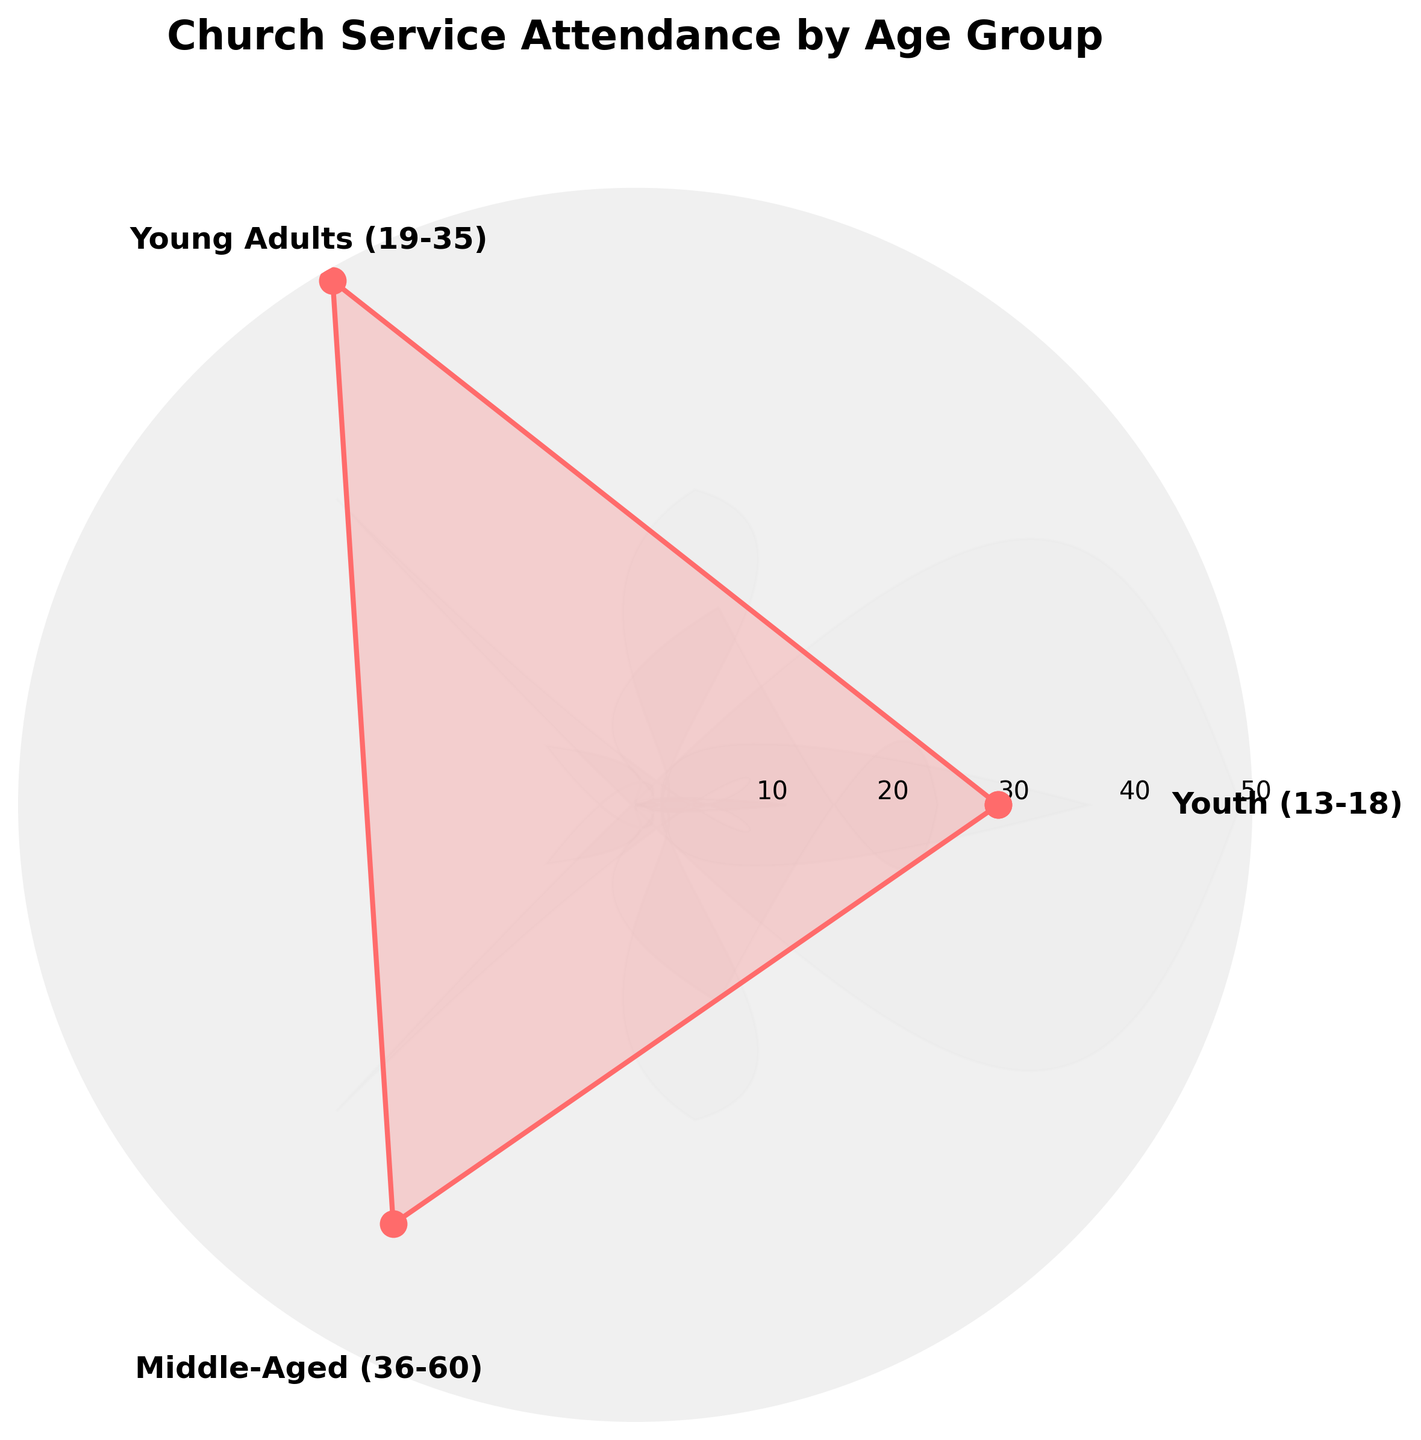What is the title of the figure? The title of the figure is displayed at the top and prominently set in bold.
Answer: Church Service Attendance by Age Group How many age groups are represented in this chart? The chart shows three labeled segments, signifying three age groups.
Answer: Three Which age group has the highest attendance? By observing the plot, the group with the largest distance from the center represents the highest attendance.
Answer: Young Adults (19-35) What is the attendance difference between the Youth (13-18) and Middle-Aged (36-60) groups? Subtract the attendance of the Youth group from that of the Middle-Aged group: 40 (Middle-Aged) - 30 (Youth) = 10
Answer: 10 Which age group has the smallest attendance? The group closest to the center of the plot represents the smallest attendance.
Answer: Youth (13-18) How does the attendance for Young Adults compare to the other age groups? The plot shows that the Young Adults group has a higher attendance than both the Youth and Middle-Aged groups.
Answer: Higher What is the average attendance for the three age groups? Sum the attendance values and divide by the number of groups: (30 + 50 + 40) / 3 = 120 / 3
Answer: 40 What is the shape of the chart used in the figure? The figure uses a circular plot which is characteristic of a rose chart or polar plot.
Answer: Circular/Petal-shaped 